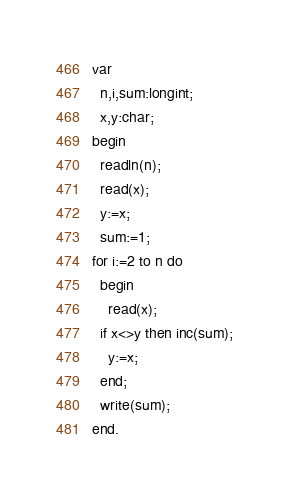<code> <loc_0><loc_0><loc_500><loc_500><_Pascal_>var
  n,i,sum:longint;
  x,y:char;
begin
  readln(n);
  read(x);
  y:=x;
  sum:=1;
for i:=2 to n do
  begin
    read(x);
  if x<>y then inc(sum);
    y:=x;
  end;
  write(sum);
end.</code> 